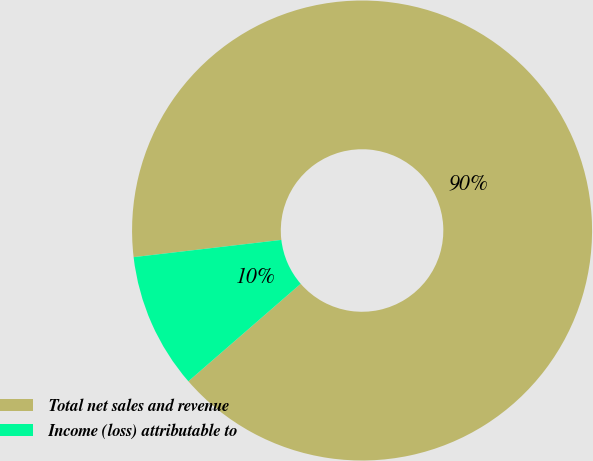<chart> <loc_0><loc_0><loc_500><loc_500><pie_chart><fcel>Total net sales and revenue<fcel>Income (loss) attributable to<nl><fcel>90.47%<fcel>9.53%<nl></chart> 